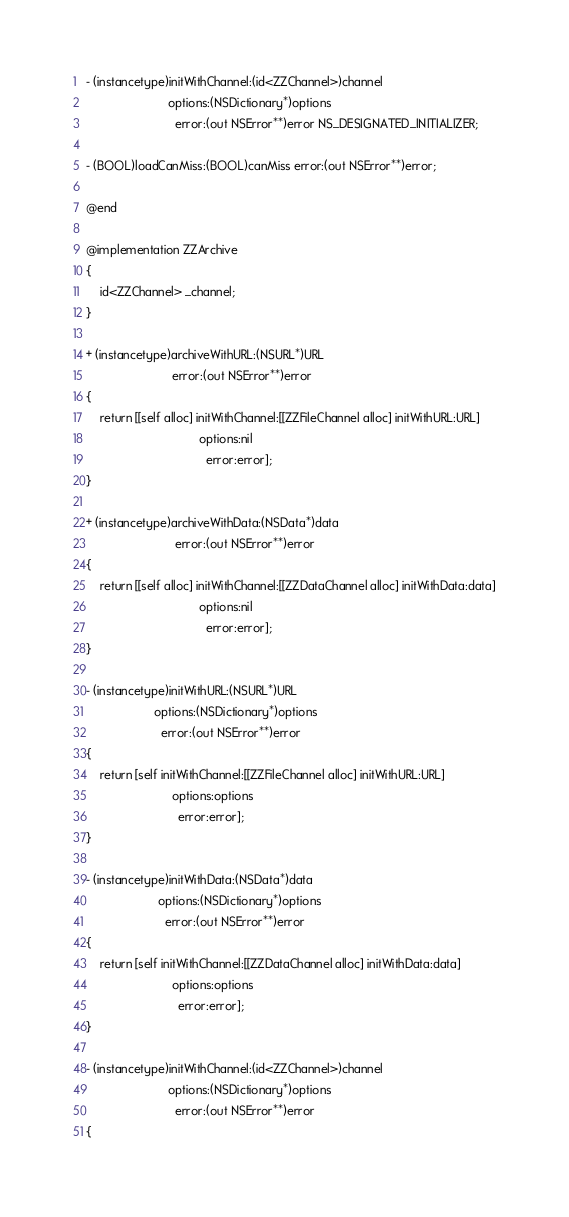Convert code to text. <code><loc_0><loc_0><loc_500><loc_500><_ObjectiveC_>
- (instancetype)initWithChannel:(id<ZZChannel>)channel
						options:(NSDictionary*)options
						  error:(out NSError**)error NS_DESIGNATED_INITIALIZER;

- (BOOL)loadCanMiss:(BOOL)canMiss error:(out NSError**)error;

@end

@implementation ZZArchive
{
	id<ZZChannel> _channel;
}

+ (instancetype)archiveWithURL:(NSURL*)URL
						 error:(out NSError**)error
{
	return [[self alloc] initWithChannel:[[ZZFileChannel alloc] initWithURL:URL]
								 options:nil
								   error:error];
}

+ (instancetype)archiveWithData:(NSData*)data
						  error:(out NSError**)error
{
	return [[self alloc] initWithChannel:[[ZZDataChannel alloc] initWithData:data]
								 options:nil
								   error:error];
}

- (instancetype)initWithURL:(NSURL*)URL
					options:(NSDictionary*)options
					  error:(out NSError**)error
{
	return [self initWithChannel:[[ZZFileChannel alloc] initWithURL:URL]
						 options:options
						   error:error];
}

- (instancetype)initWithData:(NSData*)data
					 options:(NSDictionary*)options
					   error:(out NSError**)error
{
	return [self initWithChannel:[[ZZDataChannel alloc] initWithData:data]
						 options:options
						   error:error];
}

- (instancetype)initWithChannel:(id<ZZChannel>)channel
						options:(NSDictionary*)options
						  error:(out NSError**)error
{</code> 